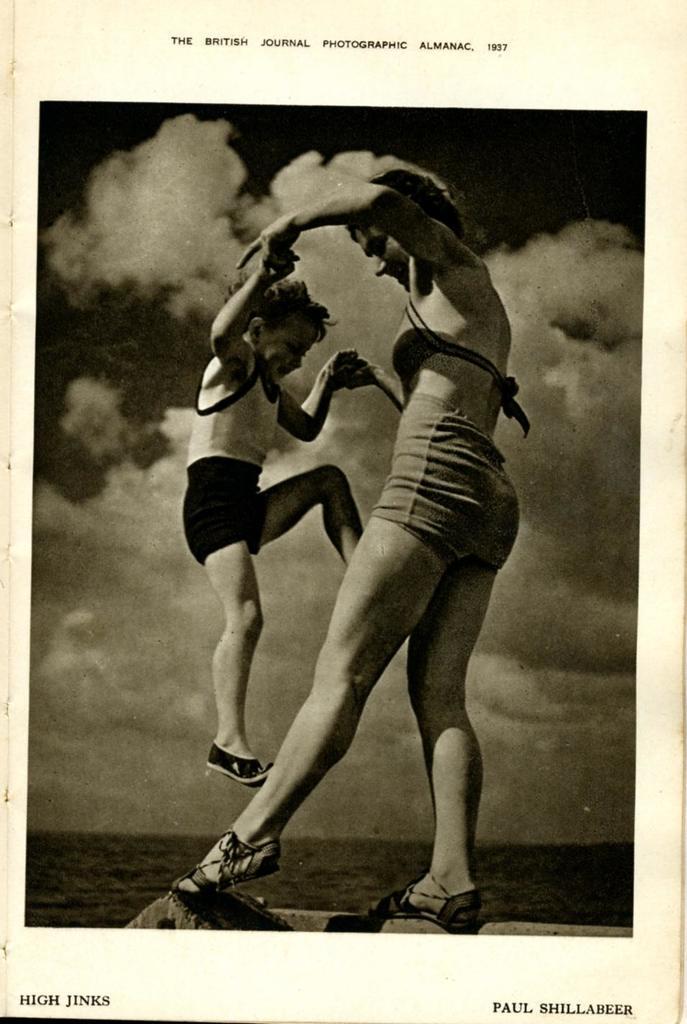Can you describe this image briefly? In the picture we can see a black and white photograph of a woman holding a boy with two hands and in the background we can see a sky with clouds. 